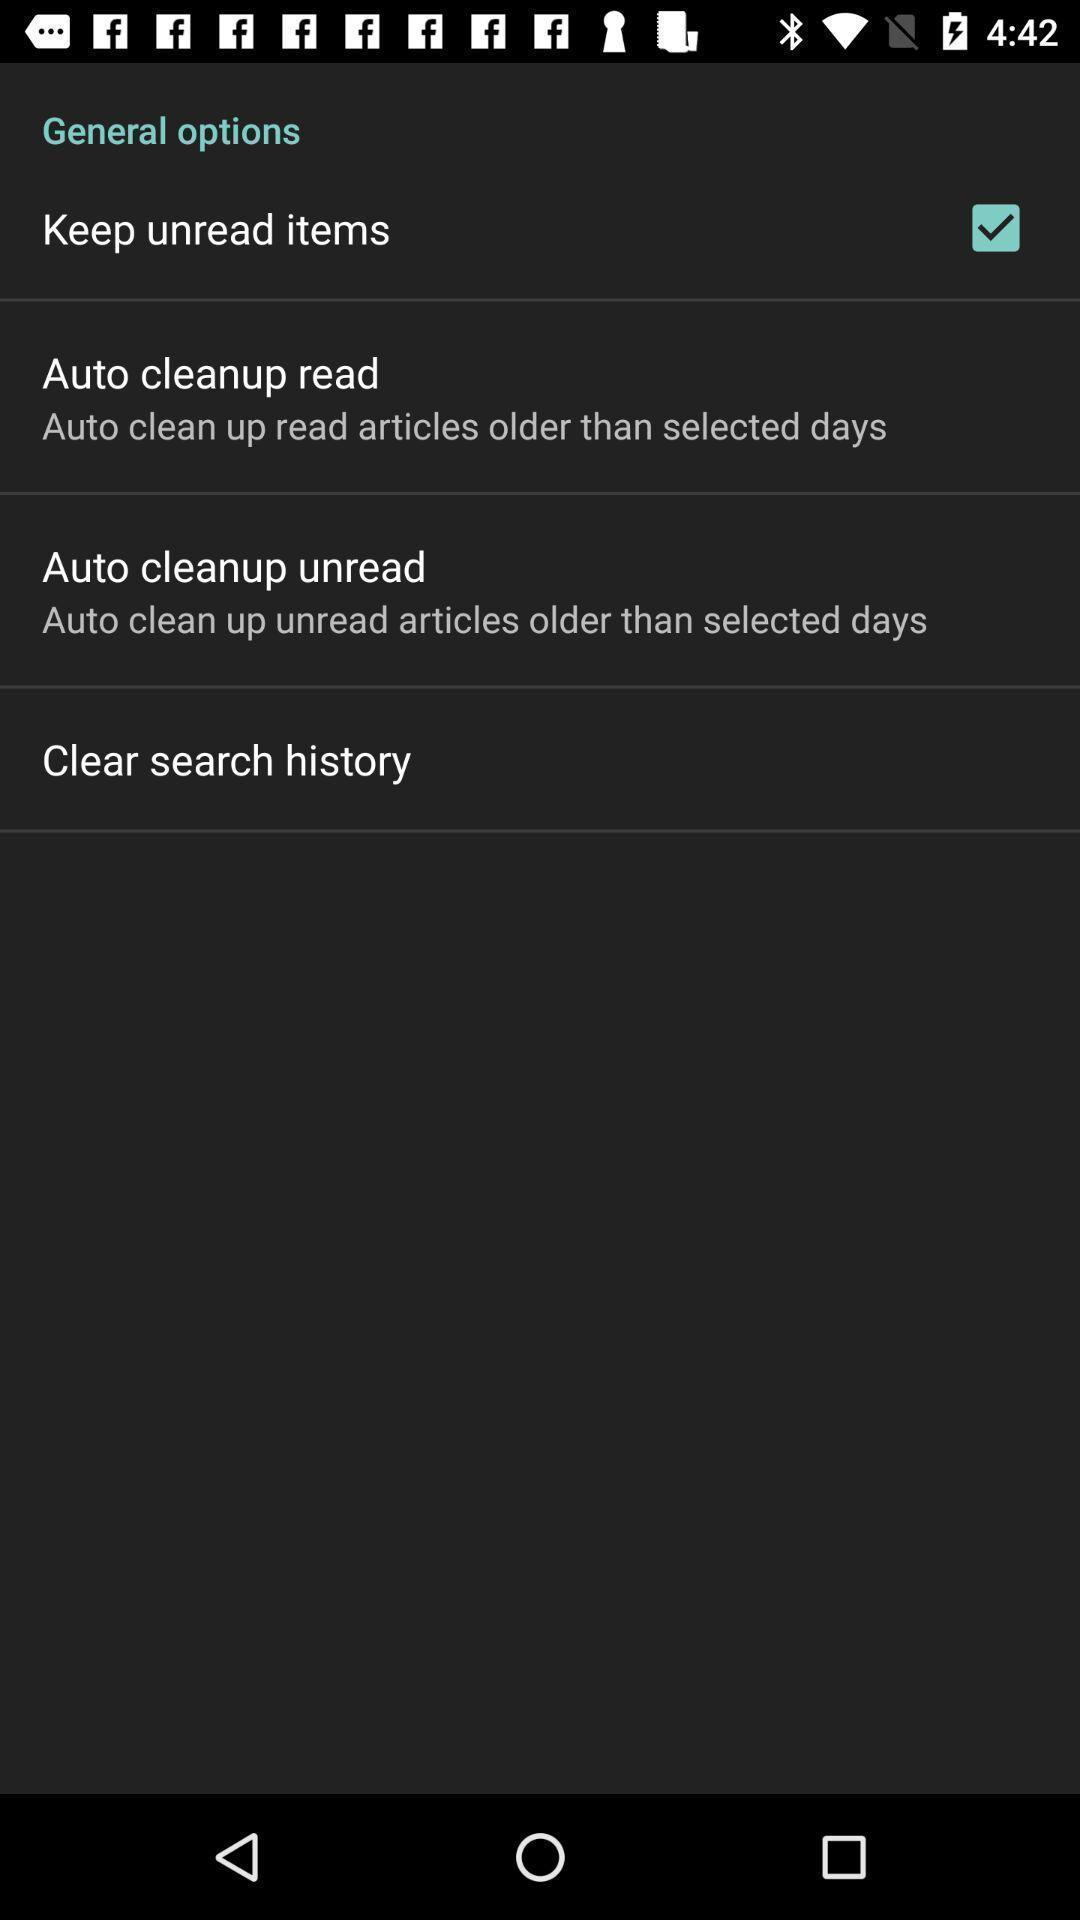Give me a narrative description of this picture. Page displaying with list of different settings. 